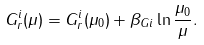<formula> <loc_0><loc_0><loc_500><loc_500>G _ { r } ^ { i } ( \mu ) = G _ { r } ^ { i } ( \mu _ { 0 } ) + \beta _ { G i } \ln \frac { \mu _ { 0 } } { \mu } .</formula> 